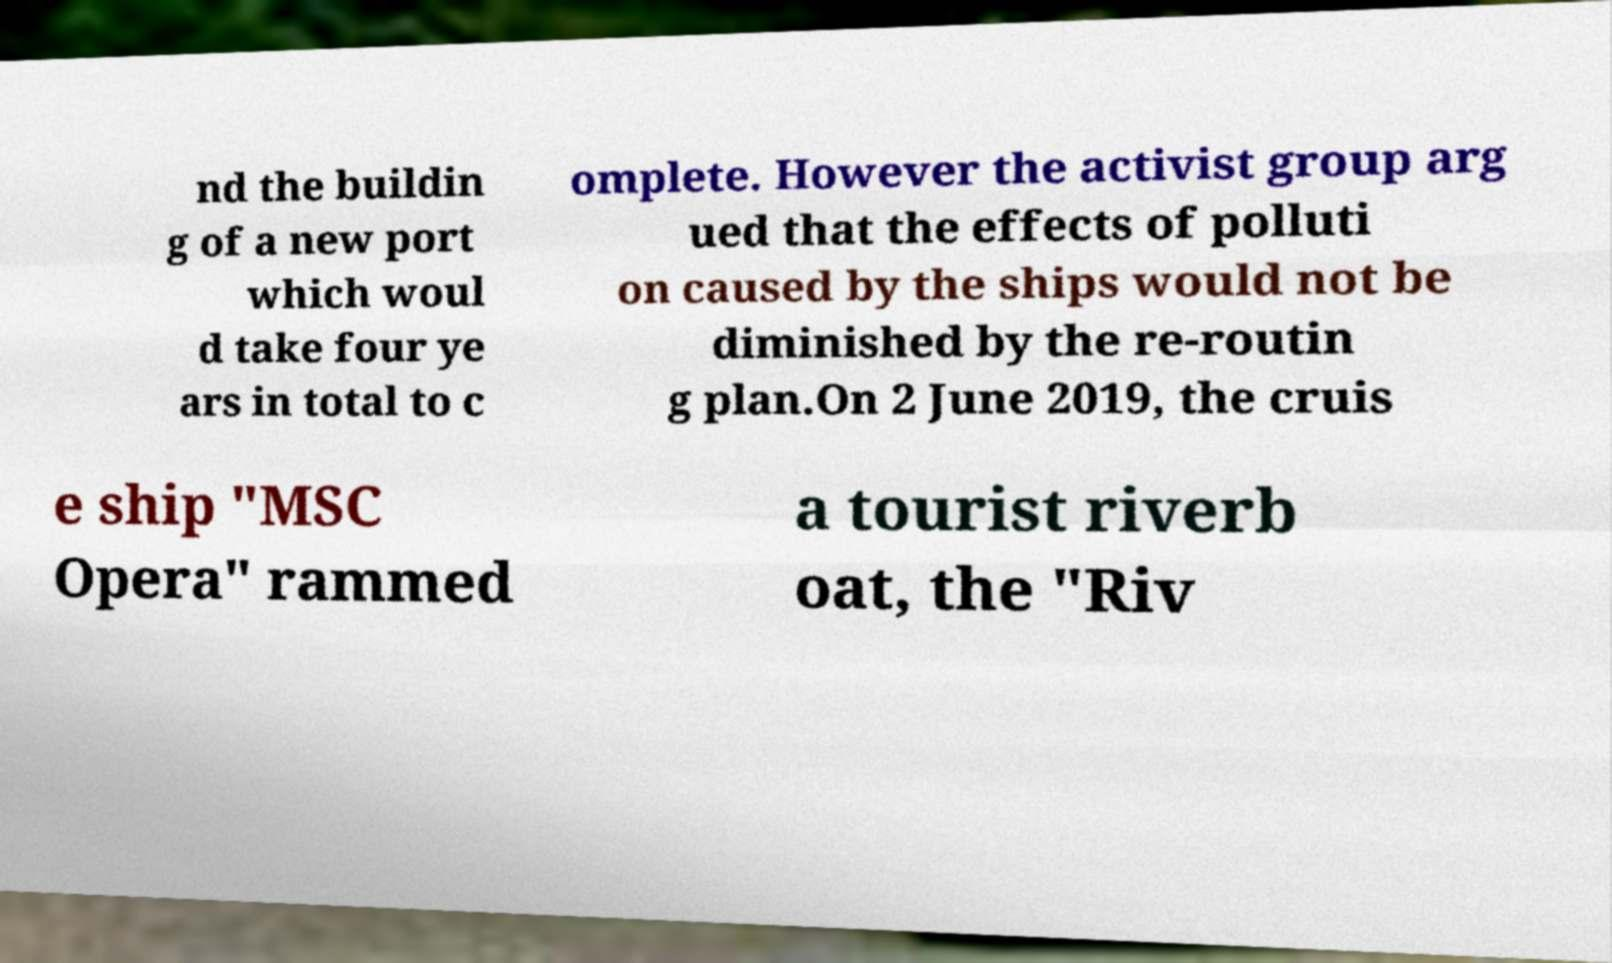What messages or text are displayed in this image? I need them in a readable, typed format. nd the buildin g of a new port which woul d take four ye ars in total to c omplete. However the activist group arg ued that the effects of polluti on caused by the ships would not be diminished by the re-routin g plan.On 2 June 2019, the cruis e ship "MSC Opera" rammed a tourist riverb oat, the "Riv 